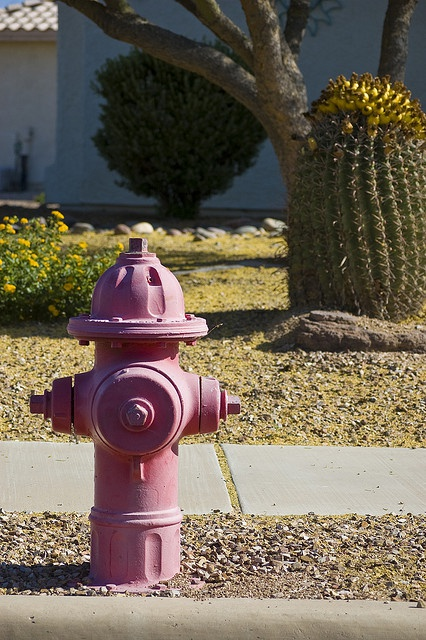Describe the objects in this image and their specific colors. I can see fire hydrant in darkgray, maroon, purple, lightpink, and pink tones, potted plant in darkgray, black, and darkblue tones, and potted plant in darkgray, black, and olive tones in this image. 